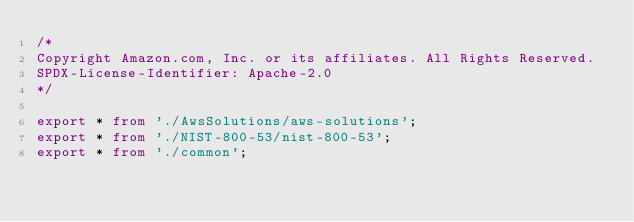Convert code to text. <code><loc_0><loc_0><loc_500><loc_500><_TypeScript_>/*
Copyright Amazon.com, Inc. or its affiliates. All Rights Reserved.
SPDX-License-Identifier: Apache-2.0
*/

export * from './AwsSolutions/aws-solutions';
export * from './NIST-800-53/nist-800-53';
export * from './common';
</code> 